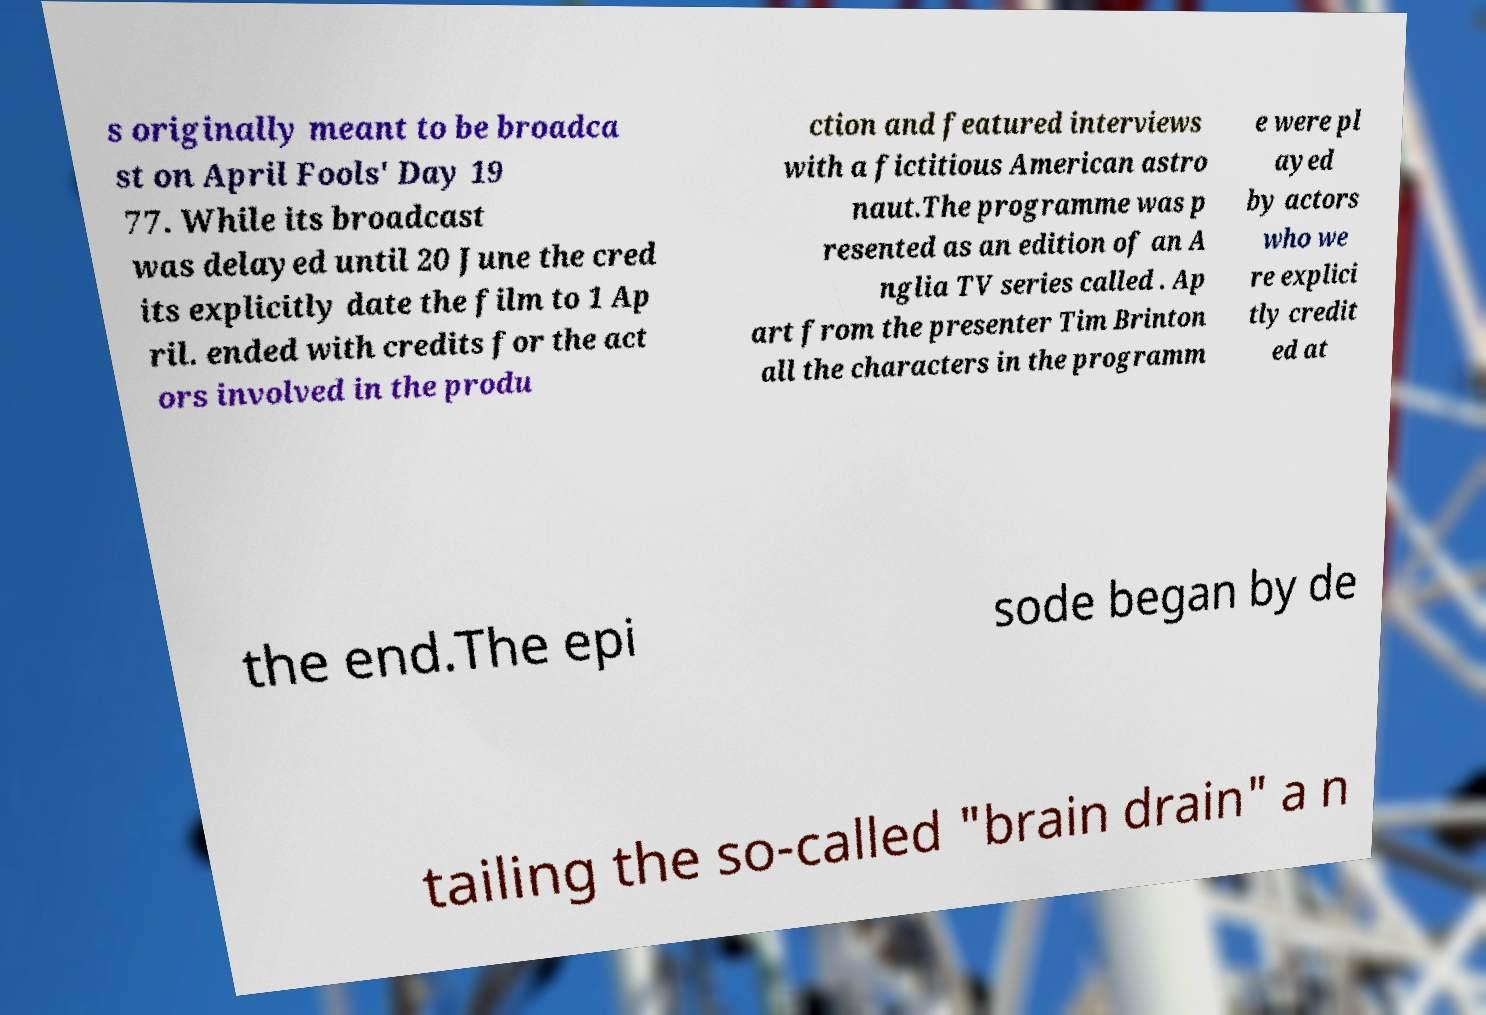Please identify and transcribe the text found in this image. s originally meant to be broadca st on April Fools' Day 19 77. While its broadcast was delayed until 20 June the cred its explicitly date the film to 1 Ap ril. ended with credits for the act ors involved in the produ ction and featured interviews with a fictitious American astro naut.The programme was p resented as an edition of an A nglia TV series called . Ap art from the presenter Tim Brinton all the characters in the programm e were pl ayed by actors who we re explici tly credit ed at the end.The epi sode began by de tailing the so-called "brain drain" a n 